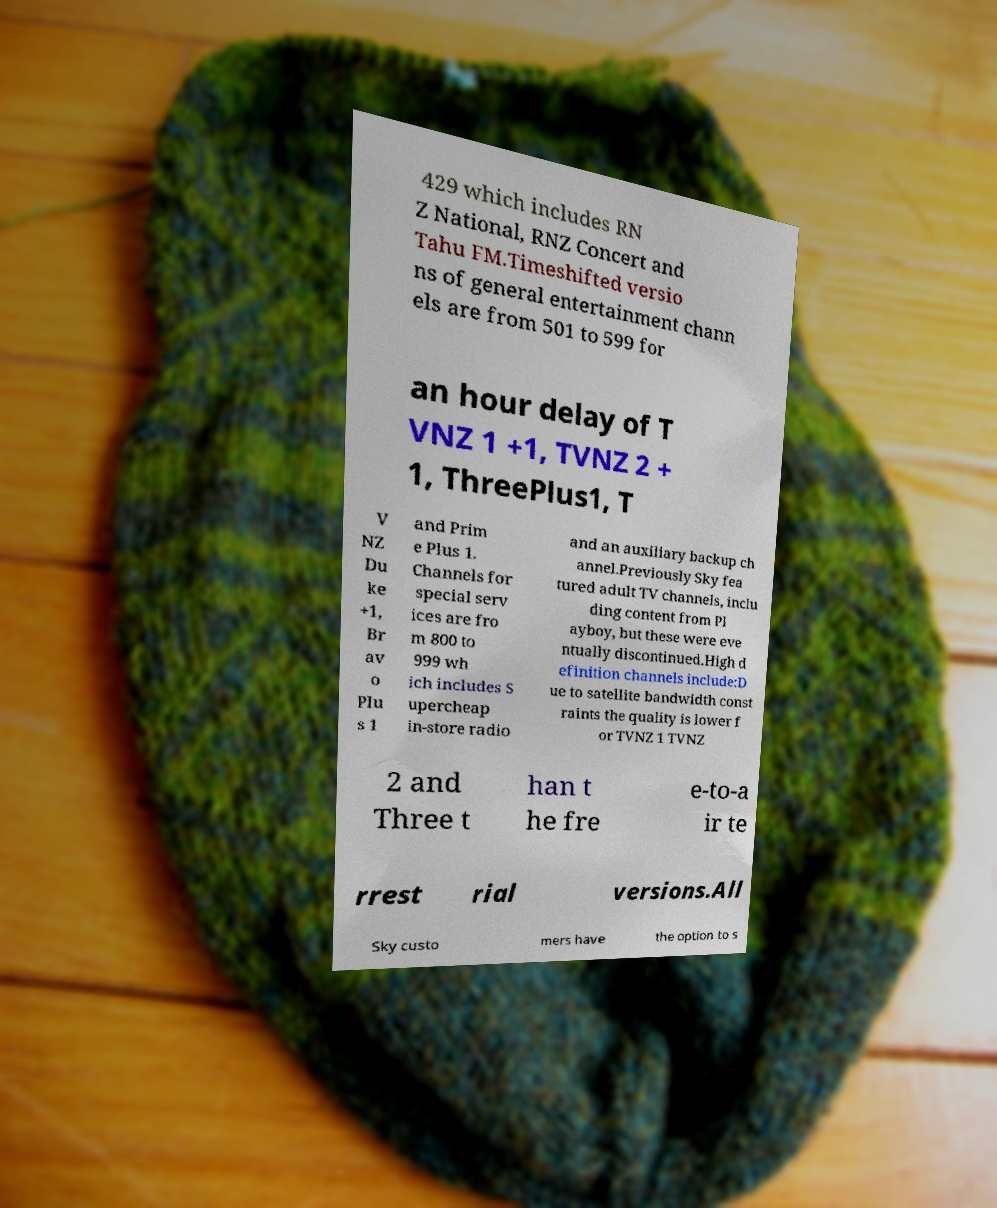I need the written content from this picture converted into text. Can you do that? 429 which includes RN Z National, RNZ Concert and Tahu FM.Timeshifted versio ns of general entertainment chann els are from 501 to 599 for an hour delay of T VNZ 1 +1, TVNZ 2 + 1, ThreePlus1, T V NZ Du ke +1, Br av o Plu s 1 and Prim e Plus 1. Channels for special serv ices are fro m 800 to 999 wh ich includes S upercheap in-store radio and an auxiliary backup ch annel.Previously Sky fea tured adult TV channels, inclu ding content from Pl ayboy, but these were eve ntually discontinued.High d efinition channels include:D ue to satellite bandwidth const raints the quality is lower f or TVNZ 1 TVNZ 2 and Three t han t he fre e-to-a ir te rrest rial versions.All Sky custo mers have the option to s 